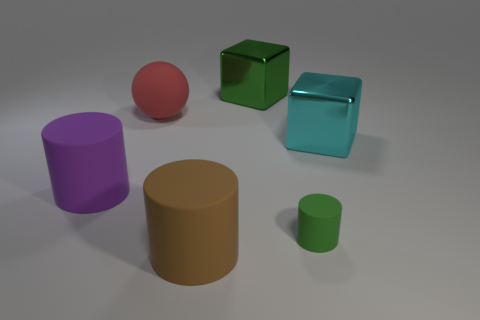There is a big shiny thing that is the same color as the tiny matte cylinder; what is its shape?
Offer a terse response. Cube. There is a metallic object that is the same size as the cyan cube; what shape is it?
Provide a succinct answer. Cube. The other object that is the same shape as the big cyan object is what color?
Give a very brief answer. Green. What number of things are either big cyan rubber balls or cyan metal things?
Provide a succinct answer. 1. There is a metallic object behind the large cyan metal block; does it have the same shape as the big rubber object behind the cyan cube?
Your answer should be compact. No. There is a tiny object right of the brown thing; what is its shape?
Provide a short and direct response. Cylinder. Are there the same number of large brown matte cylinders that are to the left of the brown thing and rubber objects behind the big red matte sphere?
Your response must be concise. Yes. How many objects are either big red objects or matte cylinders behind the brown cylinder?
Your answer should be very brief. 3. There is a large matte object that is behind the tiny rubber object and to the right of the purple rubber object; what shape is it?
Your response must be concise. Sphere. What is the material of the big cylinder that is on the left side of the large rubber cylinder in front of the big purple cylinder?
Offer a very short reply. Rubber. 